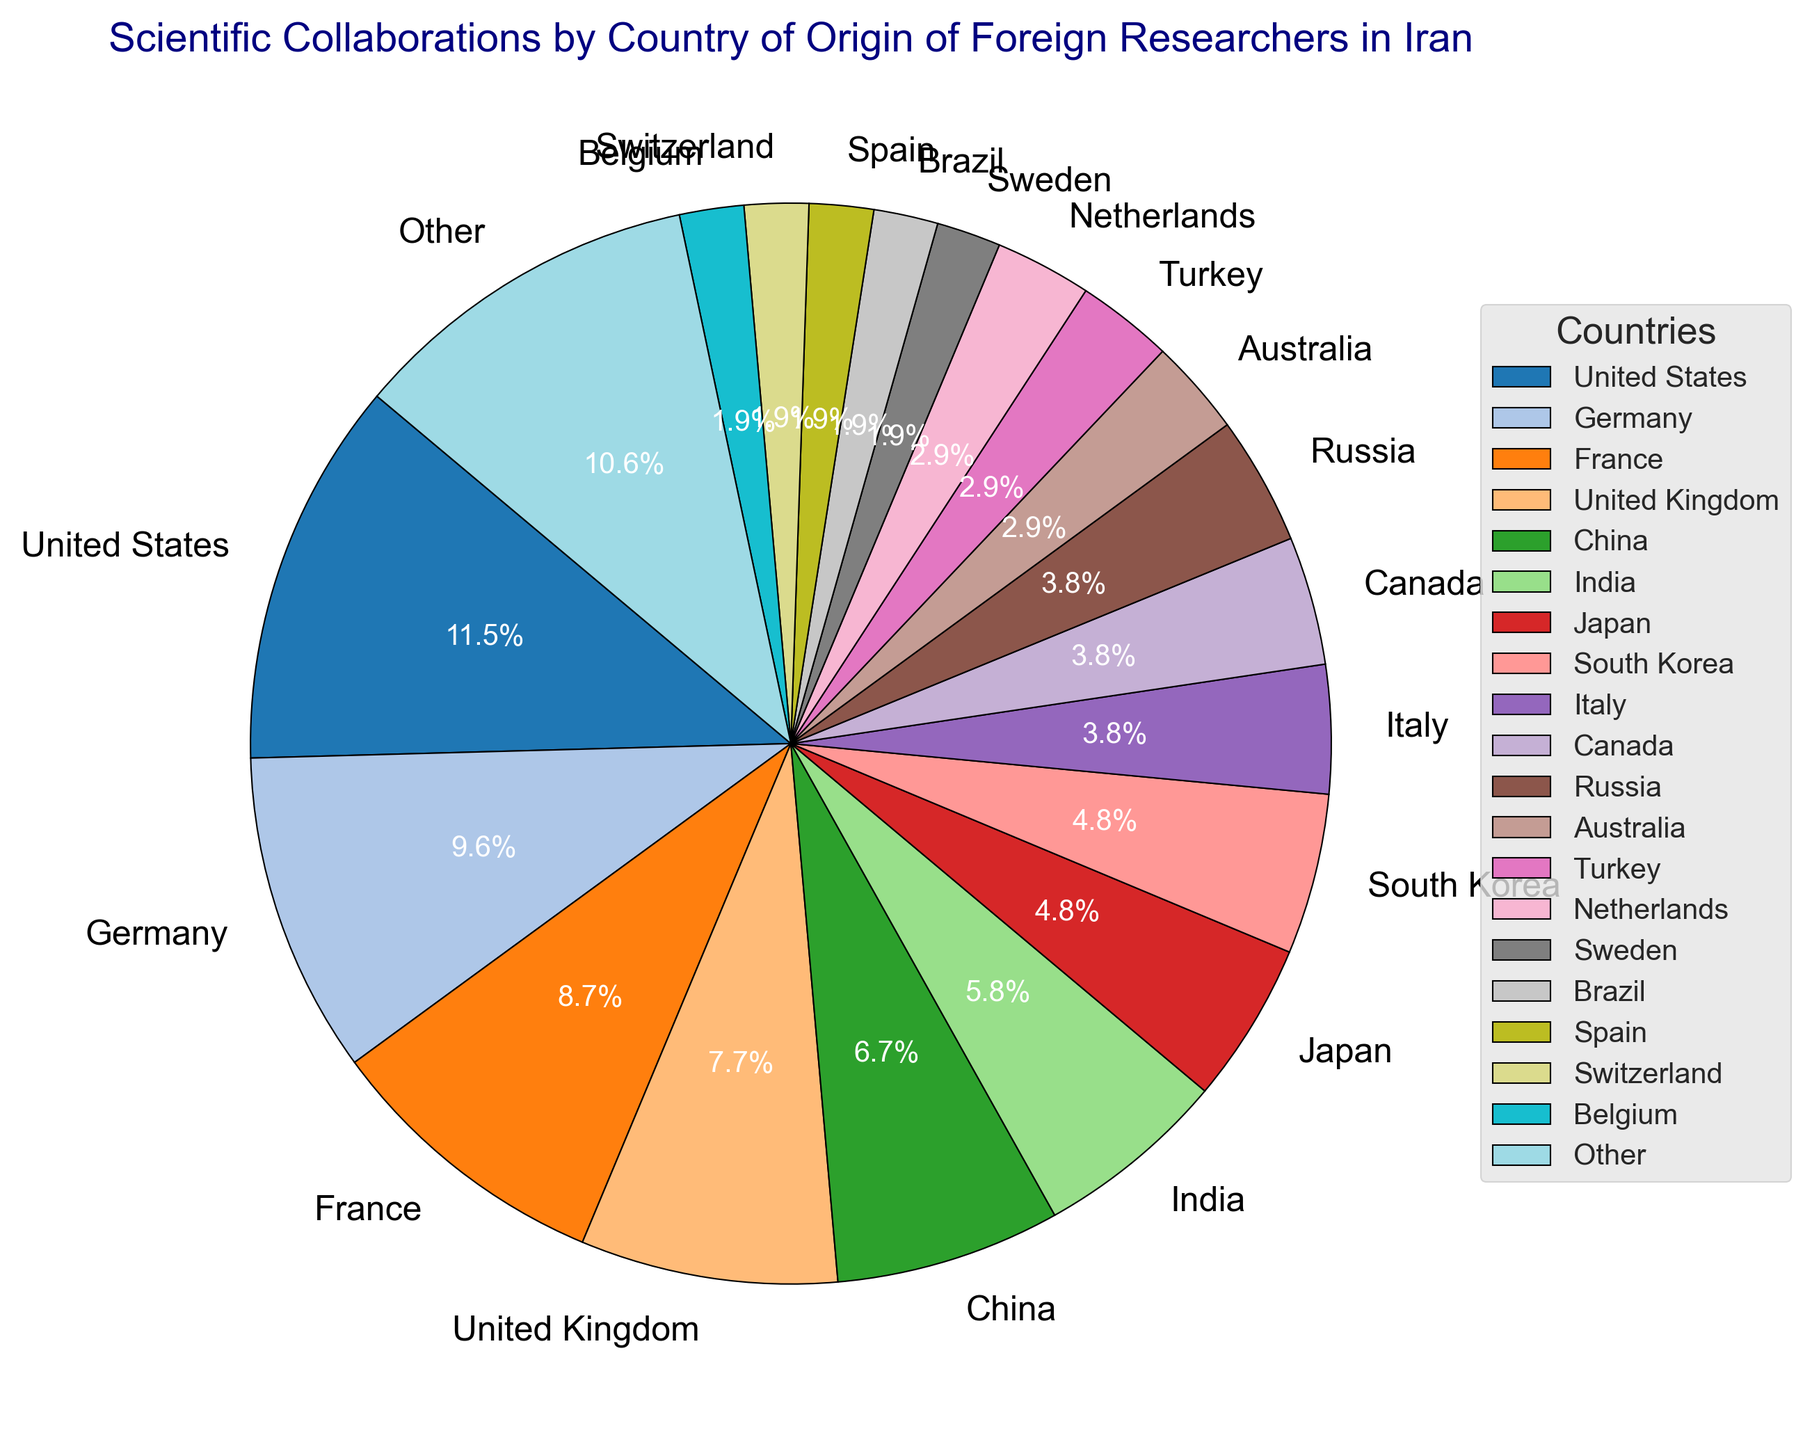What percentage of scientific collaborations come from the United States? By looking at the pie chart, specifically at the labeled wedge representing the United States, we observe that the percentage is clearly marked.
Answer: 12% Which countries contribute exactly 4% each to scientific collaborations? Examine the pie chart and identify the wedges labeled with the value 4%. According to the labels, these countries are Italy, Canada, and Russia.
Answer: Italy, Canada, Russia Which country contributes more: China or Germany? Compare the percentages labeled for China and Germany in the pie chart. China has 7%, while Germany has 10%.
Answer: Germany What is the combined contribution percentage of Turkey and Switzerland? Locate the wedges for Turkey (3%) and Switzerland (2%) and sum their percentages: 3% + 2% = 5%.
Answer: 5% What is the visual starting angle for the United States wedge? The chart begins at a start angle of 140 degrees, so the United States wedge, being the first, starts exactly at this angle.
Answer: 140 degrees How does the "Other" category compare in percentage to the contribution from Japan? Determine the values for Japan (5%) and "Other" (11%) by viewing their respective wedges and their labeled percentages. "Other" is greater.
Answer: "Other" Which country has the smallest contribution and what is its percentage? Checking the pie chart, the smallest contribution is from a few countries all contributing 2% each, such as Sweden, Brazil, Spain, Switzerland, Belgium.
Answer: Sweden, Brazil, Spain, Switzerland, Belgium (2%) What is the total percentage of collaborations from Germany, France, and the United Kingdom? Sum the percentages from Germany (10%), France (9%), and the United Kingdom (8%): 10% + 9% + 8% = 27%.
Answer: 27% Which wedges are displayed using colors in continuous color scale from the color palette? The palette used is plt.cm.tab20, which contains a continuous scale from one end of the chart to another, covering all countries' wedges from United States to "Other".
Answer: All wedges What is the combined percentage of collaborations from the top three contributing countries? Sum the percentages of the United States (12%), Germany (10%), and France (9%): 12% + 10% + 9% = 31%.
Answer: 31% 